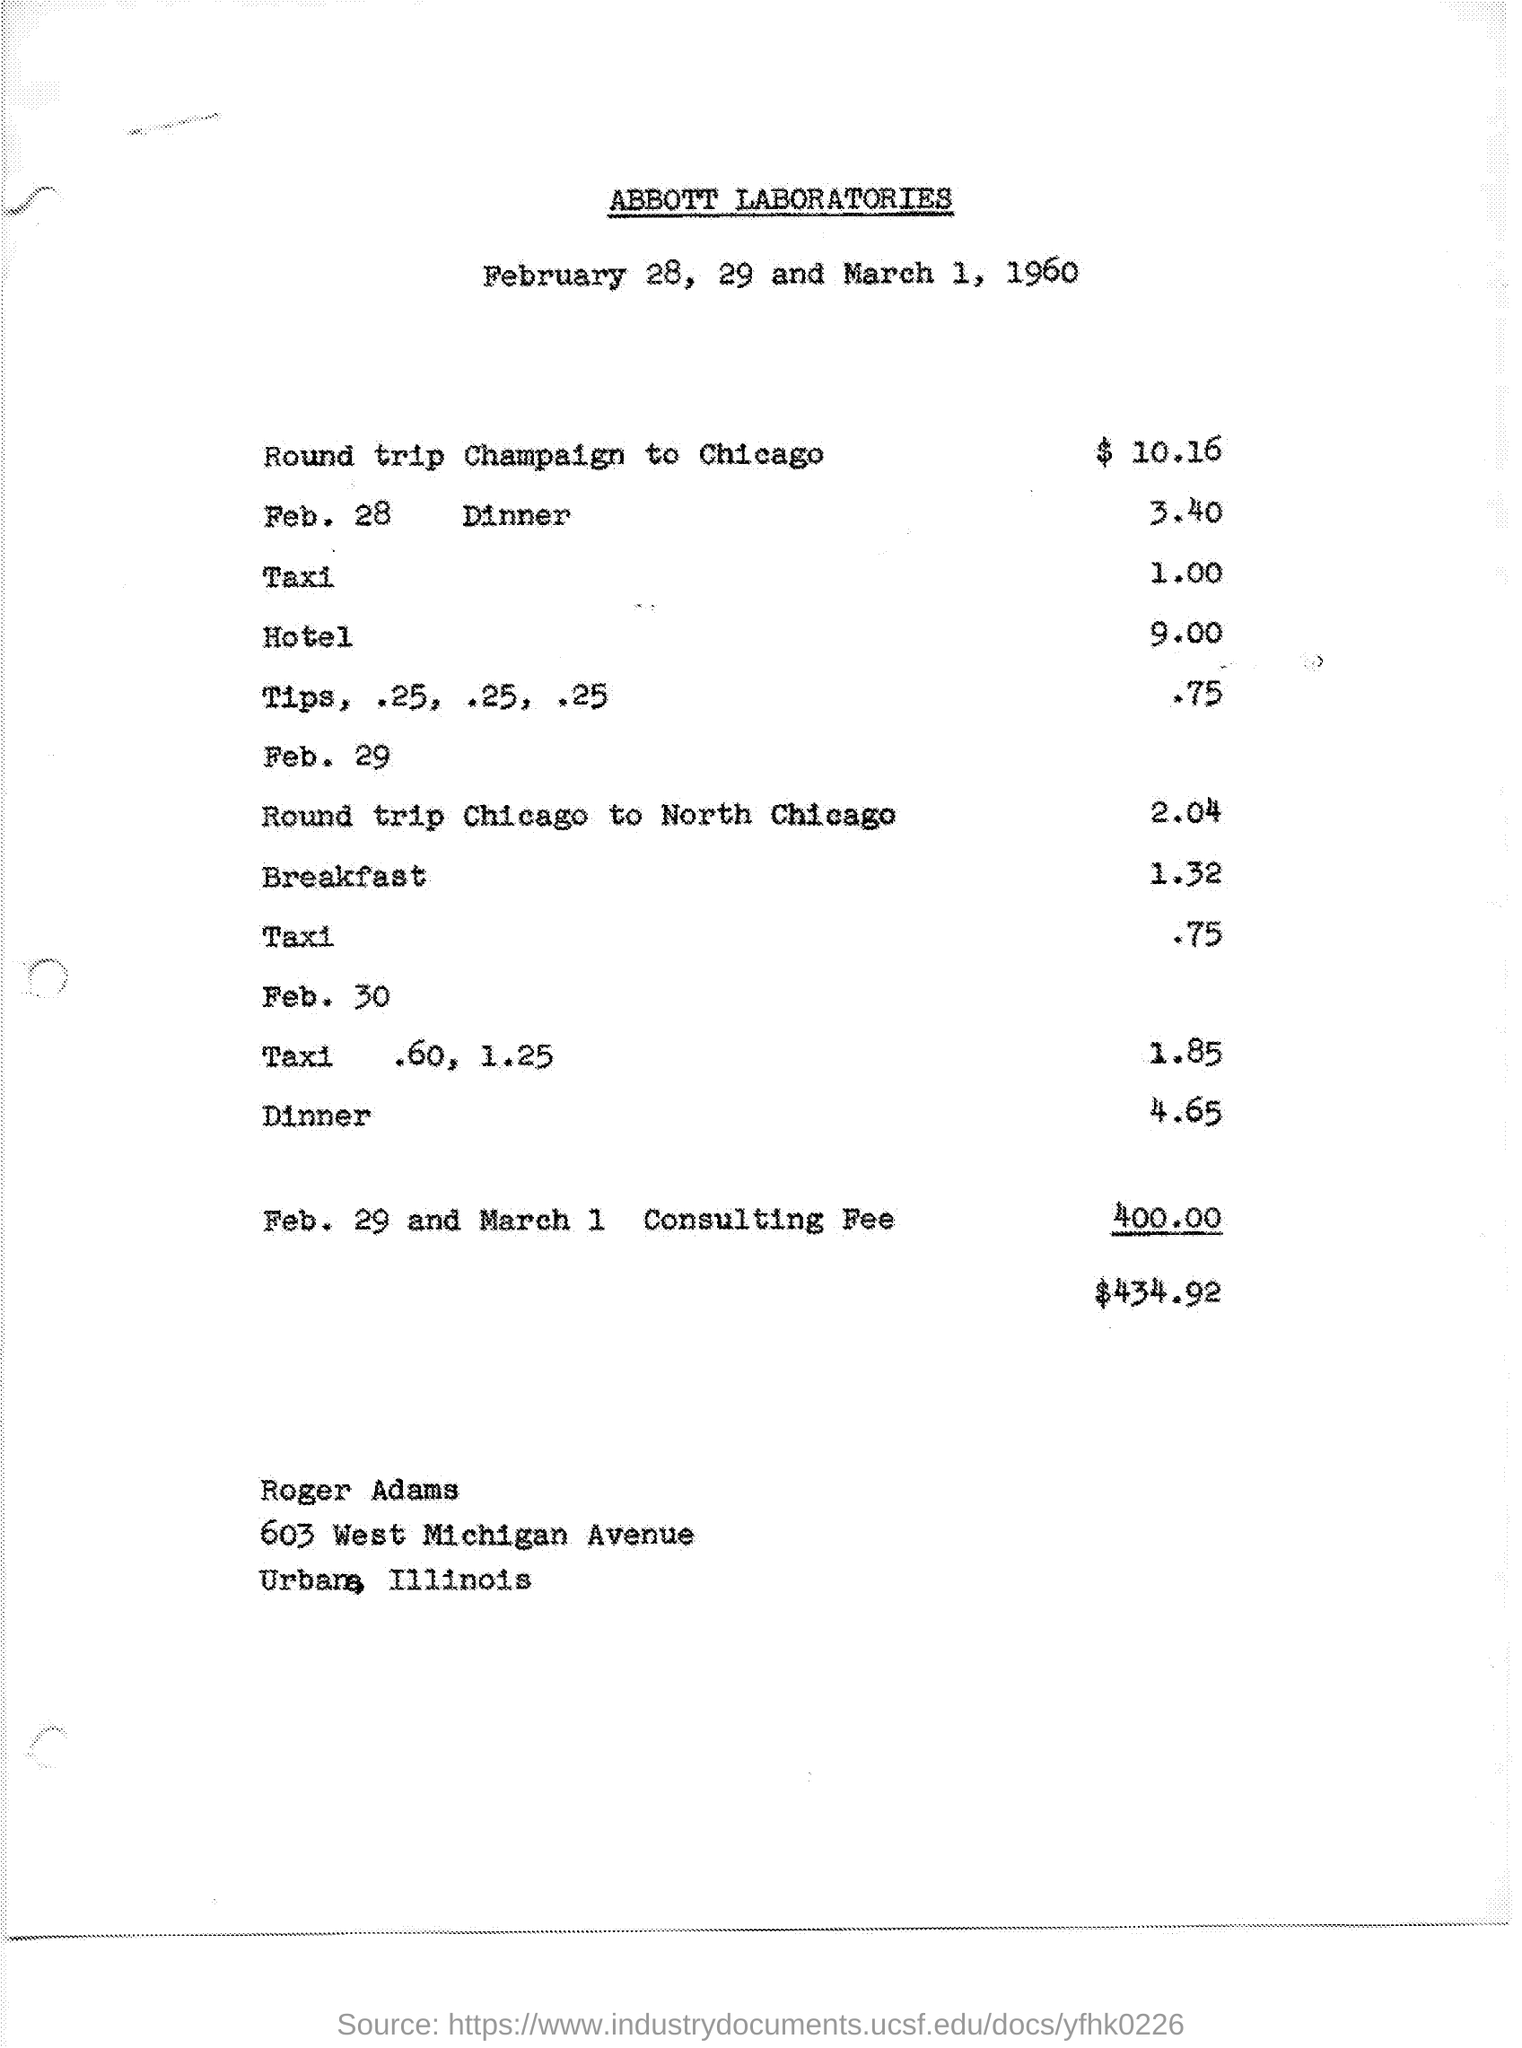What is the Cost of Round Trip Champaign to Chicago?
Provide a short and direct response. $10 16. What is the Cost of Feb. 28 Dinner?
Offer a terse response. 3 40. What is the Cost of Round Trip Chicago to North Chicago?
Your response must be concise. 2.04. What is the Title of the document?
Your answer should be compact. Abbott Laboratories. 